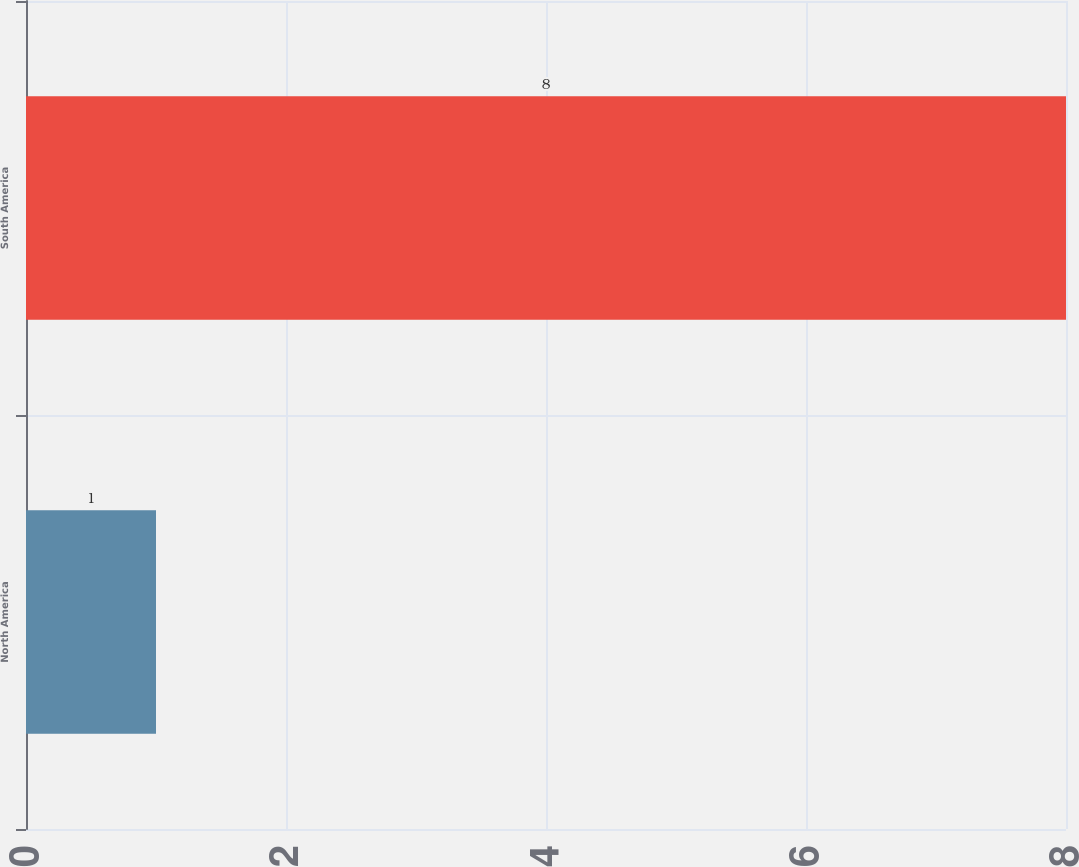Convert chart. <chart><loc_0><loc_0><loc_500><loc_500><bar_chart><fcel>North America<fcel>South America<nl><fcel>1<fcel>8<nl></chart> 